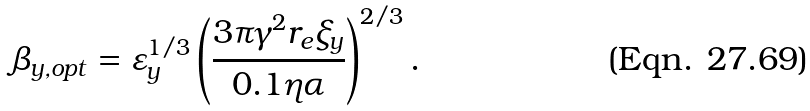Convert formula to latex. <formula><loc_0><loc_0><loc_500><loc_500>\beta _ { y , o p t } = \varepsilon _ { y } ^ { 1 / 3 } \left ( \frac { 3 \pi \gamma ^ { 2 } r _ { e } \xi _ { y } } { 0 . 1 \eta \alpha } \right ) ^ { 2 / 3 } .</formula> 